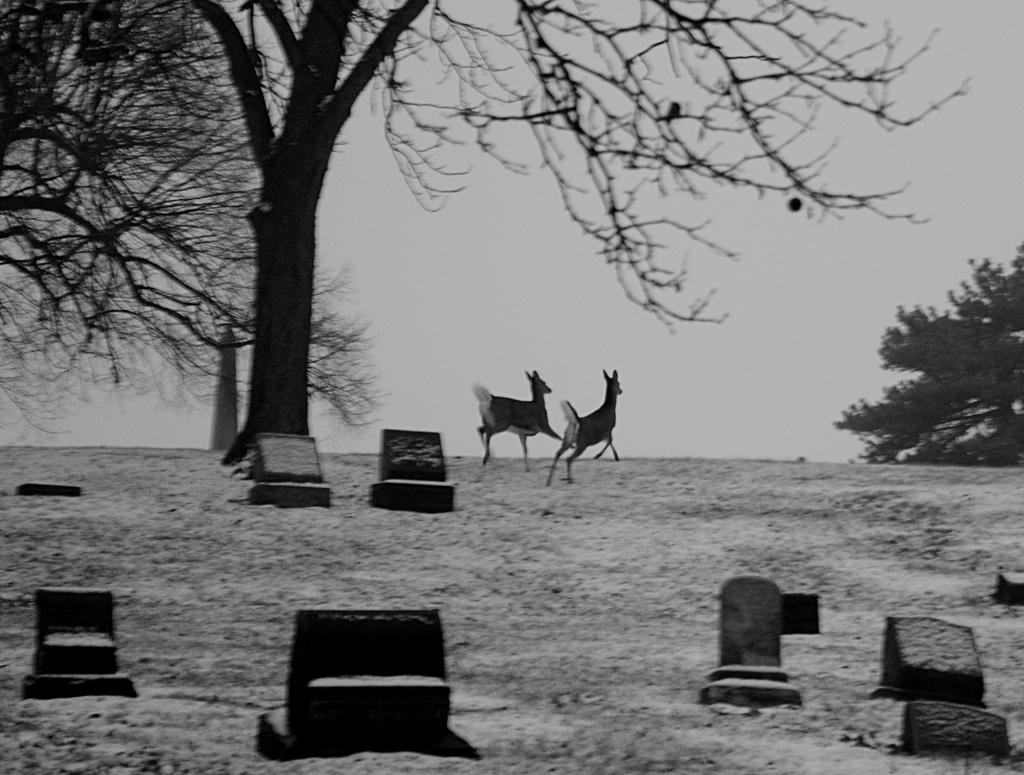What can be found at the bottom of the image? There are graves at the bottom of the image. What is located in the middle of the image? There are two animals and trees in the middle of the image. What is visible at the top of the image? The sky is visible at the top of the image. Where is the book located in the image? There is no book present in the image. What type of throne can be seen in the middle of the image? There is no throne present in the image. 